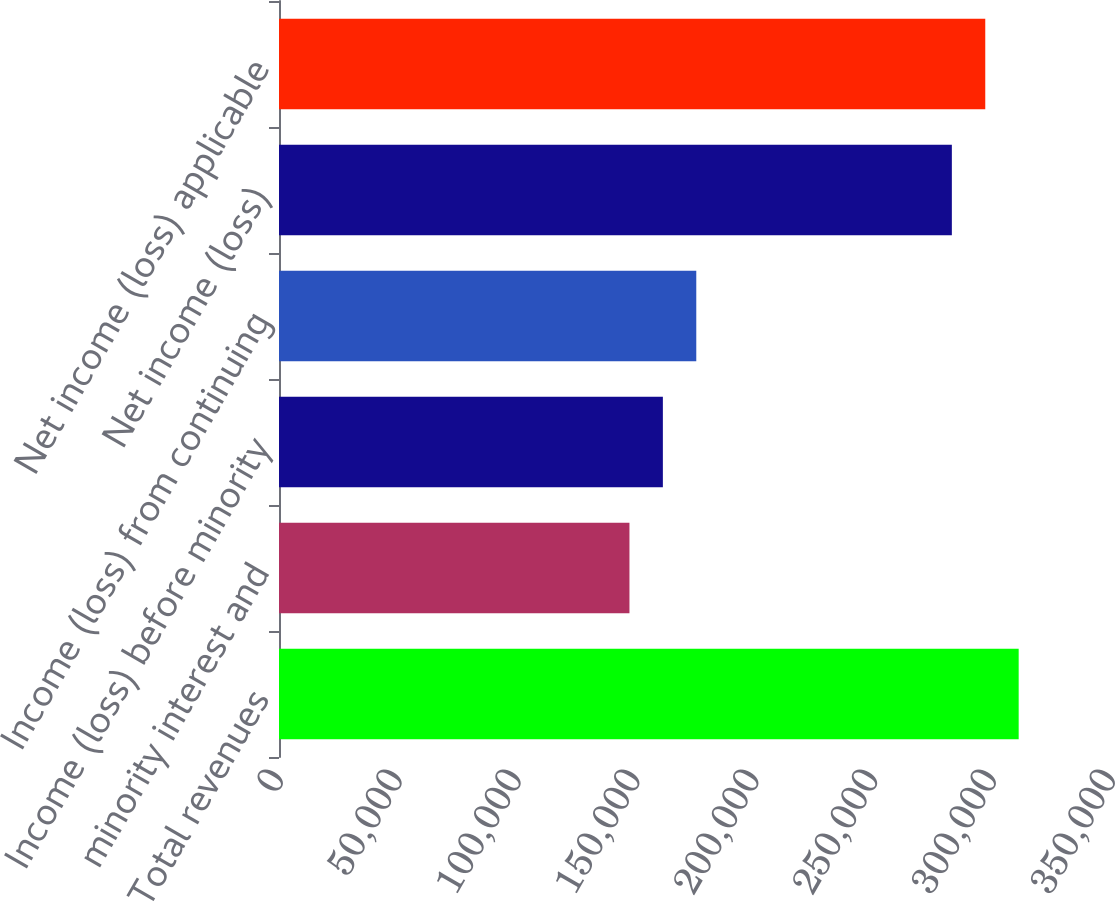Convert chart to OTSL. <chart><loc_0><loc_0><loc_500><loc_500><bar_chart><fcel>Total revenues<fcel>minority interest and<fcel>Income (loss) before minority<fcel>Income (loss) from continuing<fcel>Net income (loss)<fcel>Net income (loss) applicable<nl><fcel>311162<fcel>147428<fcel>161483<fcel>175539<fcel>283051<fcel>297106<nl></chart> 